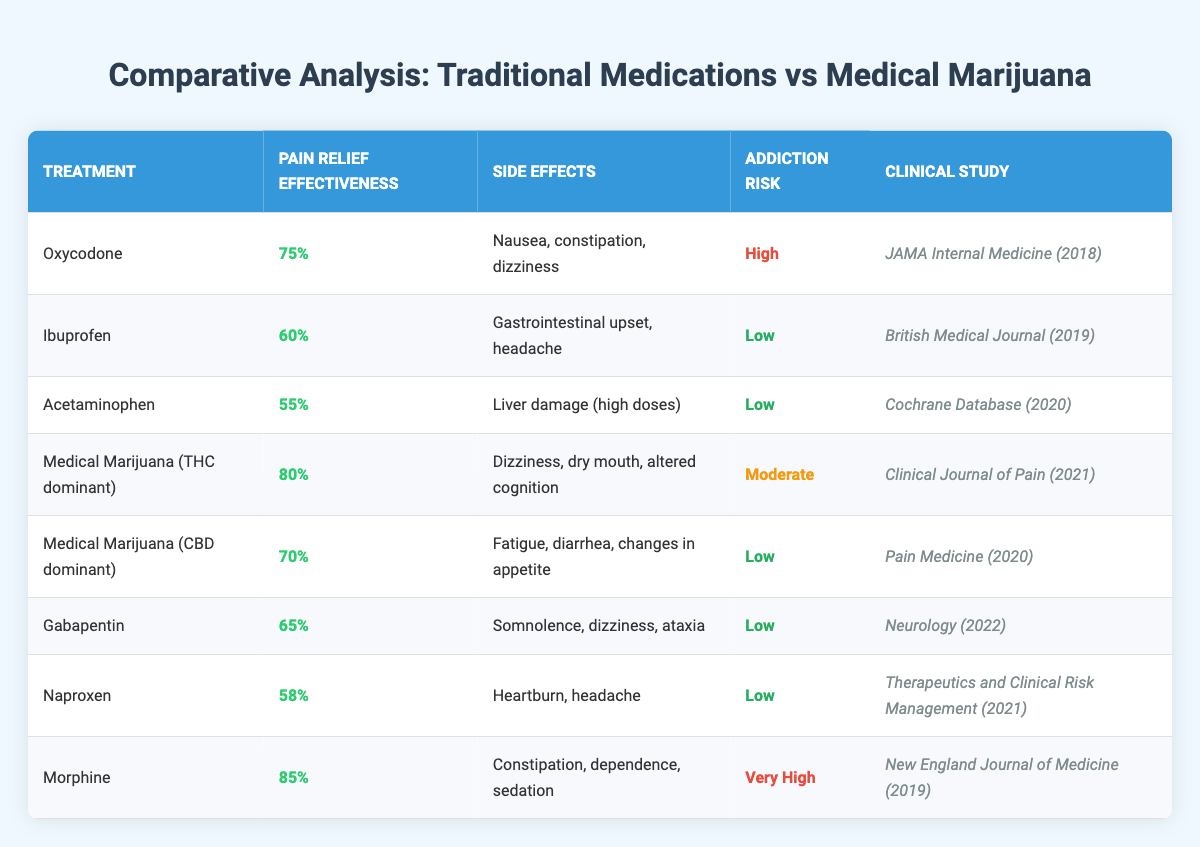What is the pain relief effectiveness of Medical Marijuana (THC dominant)? The table shows that the pain relief effectiveness for Medical Marijuana (THC dominant) is listed as 80%.
Answer: 80% Which treatment has the highest addiction risk according to the table? The table indicates that Morphine has the highest addiction risk classified as "Very High".
Answer: Morphine What is the pain relief effectiveness of Ibuprofen and how does it compare to Acetaminophen? Ibuprofen's pain relief effectiveness is 60%, while Acetaminophen's effectiveness is 55%. Therefore, Ibuprofen is more effective than Acetaminophen by 5%.
Answer: Ibuprofen is 60%, Acetaminophen 55% (5% more effective) Are the side effects of Medical Marijuana (CBD dominant) listed in the table? Yes, the side effects of Medical Marijuana (CBD dominant) including fatigue, diarrhea, and changes in appetite are specified in the table.
Answer: Yes What is the average pain relief effectiveness of traditional medications (Oxycodone, Ibuprofen, Acetaminophen, Gabapentin, and Naproxen)? The pain relief effectiveness percentages for these five medications are 75%, 60%, 55%, 65%, and 58%. When summed up (75 + 60 + 55 + 65 + 58 = 313) and divided by 5 gives an average of 62.6%.
Answer: 62.6% Which treatment has the least effective pain relief according to the data? The treatment with the least effective pain relief is Acetaminophen, which has a pain relief effectiveness of 55%.
Answer: Acetaminophen Is the addiction risk of Medical Marijuana (THC dominant) higher than that of Ibuprofen? Medical Marijuana (THC dominant) has a moderate addiction risk, while Ibuprofen has a low addiction risk. Therefore, the addiction risk of Medical Marijuana (THC dominant) is indeed higher than that of Ibuprofen.
Answer: Yes What is the difference in pain relief effectiveness between Morphine and Medical Marijuana (THC dominant)? Morphine has a pain relief effectiveness of 85% and Medical Marijuana (THC dominant) has 80%. The difference is calculated as 85% - 80% = 5%.
Answer: 5% Which treatment has a side effect of alteration in cognition? The side effect of alteration in cognition is listed for Medical Marijuana (THC dominant).
Answer: Medical Marijuana (THC dominant) How many treatments listed have a low addiction risk? The treatments with low addiction risk in the table are Ibuprofen, Acetaminophen, Medical Marijuana (CBD dominant), Gabapentin, and Naproxen, totaling 5 treatments.
Answer: 5 What is the relationship between pain relief effectiveness and addiction risk for the treatments mentioned? By observing the table, treatments with higher pain relief effectiveness tend to have higher addiction risks (e.g., Morphine) while those with lower effectiveness (e.g., Acetaminophen) have low addiction risks. This suggests a possible inverse relationship.
Answer: Higher effectiveness may relate to higher addiction risk 